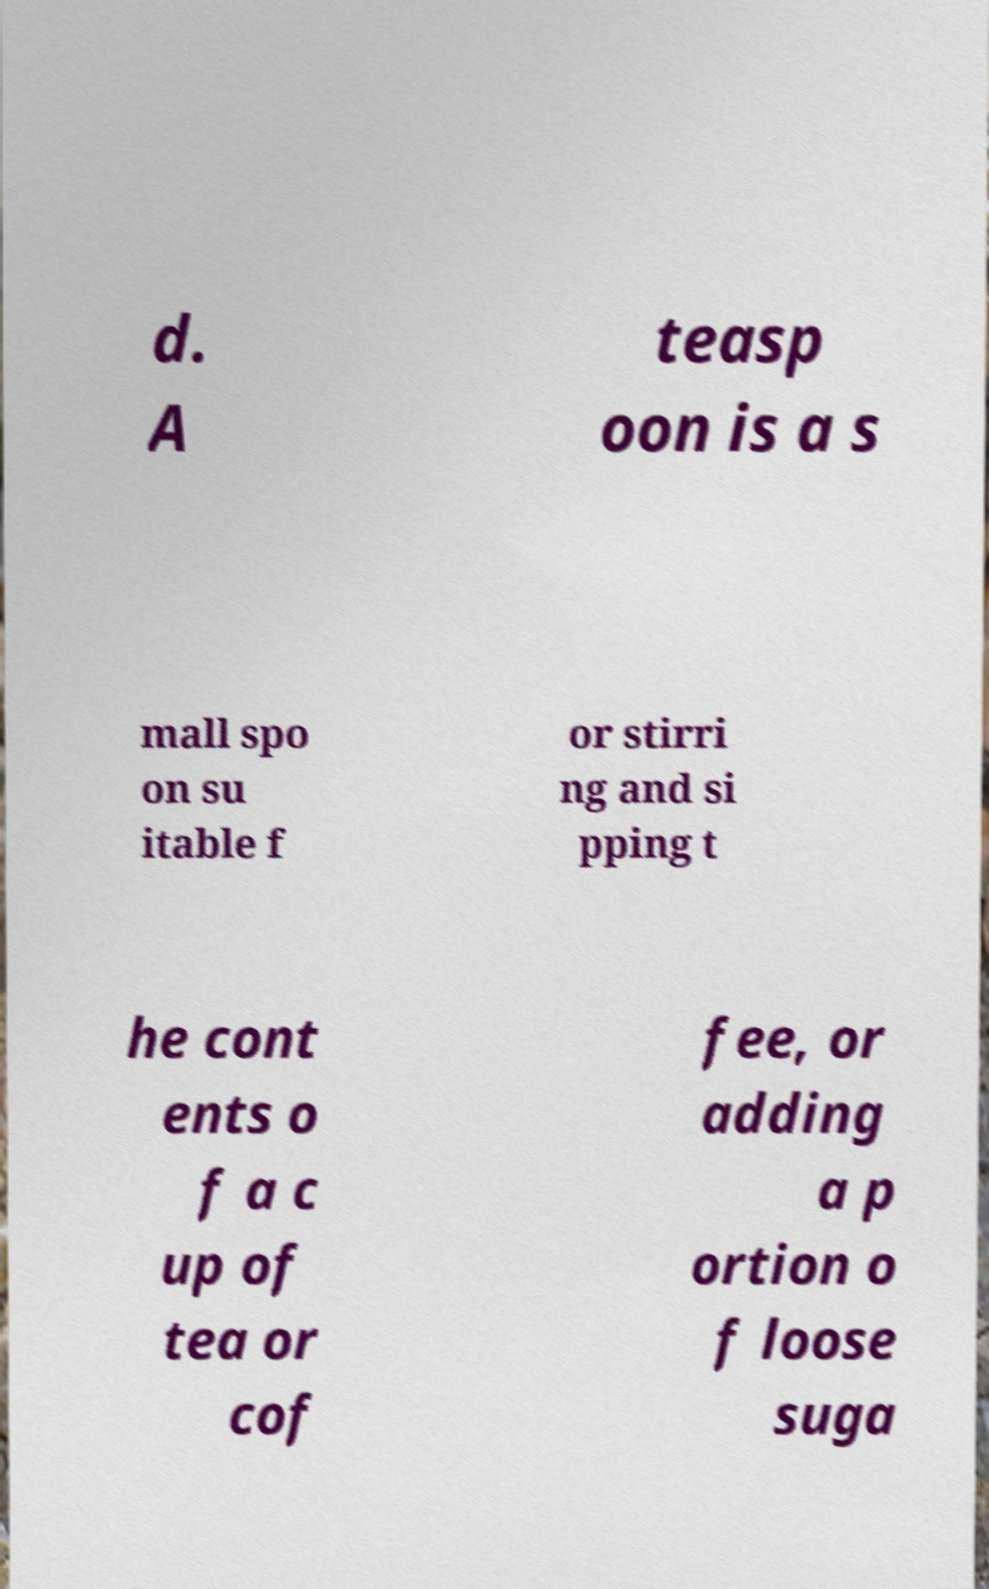Can you read and provide the text displayed in the image?This photo seems to have some interesting text. Can you extract and type it out for me? d. A teasp oon is a s mall spo on su itable f or stirri ng and si pping t he cont ents o f a c up of tea or cof fee, or adding a p ortion o f loose suga 